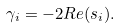<formula> <loc_0><loc_0><loc_500><loc_500>\gamma _ { i } = - 2 R e ( s _ { i } ) .</formula> 